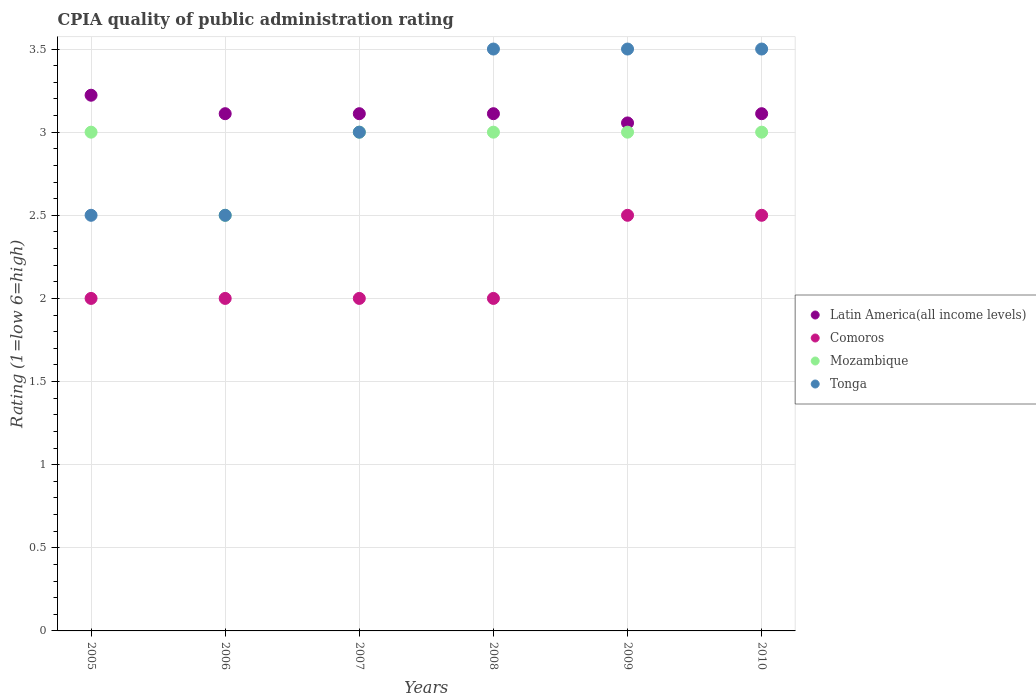How many different coloured dotlines are there?
Make the answer very short. 4. Is the number of dotlines equal to the number of legend labels?
Your answer should be very brief. Yes. What is the average CPIA rating in Comoros per year?
Give a very brief answer. 2.17. In the year 2007, what is the difference between the CPIA rating in Comoros and CPIA rating in Latin America(all income levels)?
Give a very brief answer. -1.11. Is the difference between the CPIA rating in Comoros in 2006 and 2008 greater than the difference between the CPIA rating in Latin America(all income levels) in 2006 and 2008?
Your answer should be very brief. No. What is the difference between the highest and the second highest CPIA rating in Latin America(all income levels)?
Provide a succinct answer. 0.11. What is the difference between the highest and the lowest CPIA rating in Mozambique?
Your answer should be very brief. 0.5. Is the sum of the CPIA rating in Latin America(all income levels) in 2005 and 2009 greater than the maximum CPIA rating in Comoros across all years?
Make the answer very short. Yes. Is it the case that in every year, the sum of the CPIA rating in Mozambique and CPIA rating in Comoros  is greater than the sum of CPIA rating in Latin America(all income levels) and CPIA rating in Tonga?
Offer a terse response. No. Is it the case that in every year, the sum of the CPIA rating in Tonga and CPIA rating in Latin America(all income levels)  is greater than the CPIA rating in Comoros?
Offer a terse response. Yes. Is the CPIA rating in Latin America(all income levels) strictly less than the CPIA rating in Comoros over the years?
Offer a terse response. No. How many dotlines are there?
Your answer should be very brief. 4. How many years are there in the graph?
Offer a very short reply. 6. What is the difference between two consecutive major ticks on the Y-axis?
Your answer should be very brief. 0.5. Does the graph contain any zero values?
Ensure brevity in your answer.  No. How many legend labels are there?
Your response must be concise. 4. What is the title of the graph?
Offer a very short reply. CPIA quality of public administration rating. What is the label or title of the Y-axis?
Your response must be concise. Rating (1=low 6=high). What is the Rating (1=low 6=high) of Latin America(all income levels) in 2005?
Your answer should be very brief. 3.22. What is the Rating (1=low 6=high) of Latin America(all income levels) in 2006?
Make the answer very short. 3.11. What is the Rating (1=low 6=high) of Comoros in 2006?
Ensure brevity in your answer.  2. What is the Rating (1=low 6=high) in Mozambique in 2006?
Offer a very short reply. 2.5. What is the Rating (1=low 6=high) of Latin America(all income levels) in 2007?
Ensure brevity in your answer.  3.11. What is the Rating (1=low 6=high) in Mozambique in 2007?
Your answer should be very brief. 3. What is the Rating (1=low 6=high) of Tonga in 2007?
Provide a succinct answer. 3. What is the Rating (1=low 6=high) in Latin America(all income levels) in 2008?
Make the answer very short. 3.11. What is the Rating (1=low 6=high) in Mozambique in 2008?
Provide a succinct answer. 3. What is the Rating (1=low 6=high) in Tonga in 2008?
Your response must be concise. 3.5. What is the Rating (1=low 6=high) of Latin America(all income levels) in 2009?
Keep it short and to the point. 3.06. What is the Rating (1=low 6=high) of Comoros in 2009?
Your response must be concise. 2.5. What is the Rating (1=low 6=high) in Mozambique in 2009?
Give a very brief answer. 3. What is the Rating (1=low 6=high) in Tonga in 2009?
Offer a very short reply. 3.5. What is the Rating (1=low 6=high) of Latin America(all income levels) in 2010?
Give a very brief answer. 3.11. What is the Rating (1=low 6=high) in Comoros in 2010?
Provide a short and direct response. 2.5. Across all years, what is the maximum Rating (1=low 6=high) in Latin America(all income levels)?
Give a very brief answer. 3.22. Across all years, what is the minimum Rating (1=low 6=high) of Latin America(all income levels)?
Give a very brief answer. 3.06. What is the total Rating (1=low 6=high) in Latin America(all income levels) in the graph?
Provide a succinct answer. 18.72. What is the total Rating (1=low 6=high) in Comoros in the graph?
Provide a succinct answer. 13. What is the total Rating (1=low 6=high) of Mozambique in the graph?
Provide a succinct answer. 17.5. What is the difference between the Rating (1=low 6=high) in Latin America(all income levels) in 2005 and that in 2006?
Your answer should be compact. 0.11. What is the difference between the Rating (1=low 6=high) in Mozambique in 2005 and that in 2006?
Ensure brevity in your answer.  0.5. What is the difference between the Rating (1=low 6=high) of Tonga in 2005 and that in 2006?
Provide a short and direct response. 0. What is the difference between the Rating (1=low 6=high) in Comoros in 2005 and that in 2007?
Your answer should be very brief. 0. What is the difference between the Rating (1=low 6=high) in Comoros in 2005 and that in 2008?
Provide a short and direct response. 0. What is the difference between the Rating (1=low 6=high) in Mozambique in 2005 and that in 2008?
Your response must be concise. 0. What is the difference between the Rating (1=low 6=high) in Tonga in 2005 and that in 2008?
Keep it short and to the point. -1. What is the difference between the Rating (1=low 6=high) of Latin America(all income levels) in 2005 and that in 2009?
Your answer should be compact. 0.17. What is the difference between the Rating (1=low 6=high) of Comoros in 2005 and that in 2009?
Offer a terse response. -0.5. What is the difference between the Rating (1=low 6=high) of Comoros in 2005 and that in 2010?
Make the answer very short. -0.5. What is the difference between the Rating (1=low 6=high) in Latin America(all income levels) in 2006 and that in 2007?
Keep it short and to the point. 0. What is the difference between the Rating (1=low 6=high) in Comoros in 2006 and that in 2007?
Provide a succinct answer. 0. What is the difference between the Rating (1=low 6=high) of Tonga in 2006 and that in 2007?
Offer a very short reply. -0.5. What is the difference between the Rating (1=low 6=high) of Comoros in 2006 and that in 2008?
Provide a short and direct response. 0. What is the difference between the Rating (1=low 6=high) in Mozambique in 2006 and that in 2008?
Your response must be concise. -0.5. What is the difference between the Rating (1=low 6=high) of Latin America(all income levels) in 2006 and that in 2009?
Give a very brief answer. 0.06. What is the difference between the Rating (1=low 6=high) of Mozambique in 2006 and that in 2009?
Offer a very short reply. -0.5. What is the difference between the Rating (1=low 6=high) in Comoros in 2007 and that in 2008?
Provide a succinct answer. 0. What is the difference between the Rating (1=low 6=high) in Tonga in 2007 and that in 2008?
Your answer should be compact. -0.5. What is the difference between the Rating (1=low 6=high) of Latin America(all income levels) in 2007 and that in 2009?
Offer a very short reply. 0.06. What is the difference between the Rating (1=low 6=high) of Comoros in 2007 and that in 2010?
Ensure brevity in your answer.  -0.5. What is the difference between the Rating (1=low 6=high) of Tonga in 2007 and that in 2010?
Your response must be concise. -0.5. What is the difference between the Rating (1=low 6=high) in Latin America(all income levels) in 2008 and that in 2009?
Give a very brief answer. 0.06. What is the difference between the Rating (1=low 6=high) in Comoros in 2008 and that in 2009?
Offer a very short reply. -0.5. What is the difference between the Rating (1=low 6=high) in Mozambique in 2008 and that in 2009?
Your response must be concise. 0. What is the difference between the Rating (1=low 6=high) in Tonga in 2008 and that in 2009?
Provide a short and direct response. 0. What is the difference between the Rating (1=low 6=high) in Latin America(all income levels) in 2008 and that in 2010?
Your answer should be compact. 0. What is the difference between the Rating (1=low 6=high) in Comoros in 2008 and that in 2010?
Your response must be concise. -0.5. What is the difference between the Rating (1=low 6=high) in Mozambique in 2008 and that in 2010?
Ensure brevity in your answer.  0. What is the difference between the Rating (1=low 6=high) in Latin America(all income levels) in 2009 and that in 2010?
Your answer should be compact. -0.06. What is the difference between the Rating (1=low 6=high) in Comoros in 2009 and that in 2010?
Keep it short and to the point. 0. What is the difference between the Rating (1=low 6=high) in Latin America(all income levels) in 2005 and the Rating (1=low 6=high) in Comoros in 2006?
Make the answer very short. 1.22. What is the difference between the Rating (1=low 6=high) in Latin America(all income levels) in 2005 and the Rating (1=low 6=high) in Mozambique in 2006?
Your response must be concise. 0.72. What is the difference between the Rating (1=low 6=high) of Latin America(all income levels) in 2005 and the Rating (1=low 6=high) of Tonga in 2006?
Ensure brevity in your answer.  0.72. What is the difference between the Rating (1=low 6=high) in Latin America(all income levels) in 2005 and the Rating (1=low 6=high) in Comoros in 2007?
Your answer should be very brief. 1.22. What is the difference between the Rating (1=low 6=high) of Latin America(all income levels) in 2005 and the Rating (1=low 6=high) of Mozambique in 2007?
Your response must be concise. 0.22. What is the difference between the Rating (1=low 6=high) in Latin America(all income levels) in 2005 and the Rating (1=low 6=high) in Tonga in 2007?
Provide a short and direct response. 0.22. What is the difference between the Rating (1=low 6=high) of Comoros in 2005 and the Rating (1=low 6=high) of Mozambique in 2007?
Offer a terse response. -1. What is the difference between the Rating (1=low 6=high) of Comoros in 2005 and the Rating (1=low 6=high) of Tonga in 2007?
Make the answer very short. -1. What is the difference between the Rating (1=low 6=high) of Mozambique in 2005 and the Rating (1=low 6=high) of Tonga in 2007?
Provide a short and direct response. 0. What is the difference between the Rating (1=low 6=high) in Latin America(all income levels) in 2005 and the Rating (1=low 6=high) in Comoros in 2008?
Keep it short and to the point. 1.22. What is the difference between the Rating (1=low 6=high) of Latin America(all income levels) in 2005 and the Rating (1=low 6=high) of Mozambique in 2008?
Make the answer very short. 0.22. What is the difference between the Rating (1=low 6=high) of Latin America(all income levels) in 2005 and the Rating (1=low 6=high) of Tonga in 2008?
Make the answer very short. -0.28. What is the difference between the Rating (1=low 6=high) in Comoros in 2005 and the Rating (1=low 6=high) in Mozambique in 2008?
Offer a very short reply. -1. What is the difference between the Rating (1=low 6=high) in Latin America(all income levels) in 2005 and the Rating (1=low 6=high) in Comoros in 2009?
Give a very brief answer. 0.72. What is the difference between the Rating (1=low 6=high) in Latin America(all income levels) in 2005 and the Rating (1=low 6=high) in Mozambique in 2009?
Offer a terse response. 0.22. What is the difference between the Rating (1=low 6=high) in Latin America(all income levels) in 2005 and the Rating (1=low 6=high) in Tonga in 2009?
Make the answer very short. -0.28. What is the difference between the Rating (1=low 6=high) in Comoros in 2005 and the Rating (1=low 6=high) in Tonga in 2009?
Provide a succinct answer. -1.5. What is the difference between the Rating (1=low 6=high) of Latin America(all income levels) in 2005 and the Rating (1=low 6=high) of Comoros in 2010?
Your response must be concise. 0.72. What is the difference between the Rating (1=low 6=high) in Latin America(all income levels) in 2005 and the Rating (1=low 6=high) in Mozambique in 2010?
Your answer should be compact. 0.22. What is the difference between the Rating (1=low 6=high) of Latin America(all income levels) in 2005 and the Rating (1=low 6=high) of Tonga in 2010?
Provide a short and direct response. -0.28. What is the difference between the Rating (1=low 6=high) in Comoros in 2005 and the Rating (1=low 6=high) in Tonga in 2010?
Give a very brief answer. -1.5. What is the difference between the Rating (1=low 6=high) of Latin America(all income levels) in 2006 and the Rating (1=low 6=high) of Mozambique in 2007?
Keep it short and to the point. 0.11. What is the difference between the Rating (1=low 6=high) in Latin America(all income levels) in 2006 and the Rating (1=low 6=high) in Tonga in 2007?
Provide a short and direct response. 0.11. What is the difference between the Rating (1=low 6=high) of Comoros in 2006 and the Rating (1=low 6=high) of Mozambique in 2007?
Offer a very short reply. -1. What is the difference between the Rating (1=low 6=high) in Mozambique in 2006 and the Rating (1=low 6=high) in Tonga in 2007?
Your answer should be very brief. -0.5. What is the difference between the Rating (1=low 6=high) in Latin America(all income levels) in 2006 and the Rating (1=low 6=high) in Comoros in 2008?
Your answer should be compact. 1.11. What is the difference between the Rating (1=low 6=high) of Latin America(all income levels) in 2006 and the Rating (1=low 6=high) of Mozambique in 2008?
Offer a very short reply. 0.11. What is the difference between the Rating (1=low 6=high) of Latin America(all income levels) in 2006 and the Rating (1=low 6=high) of Tonga in 2008?
Give a very brief answer. -0.39. What is the difference between the Rating (1=low 6=high) of Latin America(all income levels) in 2006 and the Rating (1=low 6=high) of Comoros in 2009?
Offer a terse response. 0.61. What is the difference between the Rating (1=low 6=high) of Latin America(all income levels) in 2006 and the Rating (1=low 6=high) of Mozambique in 2009?
Offer a terse response. 0.11. What is the difference between the Rating (1=low 6=high) in Latin America(all income levels) in 2006 and the Rating (1=low 6=high) in Tonga in 2009?
Offer a very short reply. -0.39. What is the difference between the Rating (1=low 6=high) in Comoros in 2006 and the Rating (1=low 6=high) in Tonga in 2009?
Offer a terse response. -1.5. What is the difference between the Rating (1=low 6=high) in Latin America(all income levels) in 2006 and the Rating (1=low 6=high) in Comoros in 2010?
Provide a short and direct response. 0.61. What is the difference between the Rating (1=low 6=high) in Latin America(all income levels) in 2006 and the Rating (1=low 6=high) in Mozambique in 2010?
Offer a very short reply. 0.11. What is the difference between the Rating (1=low 6=high) of Latin America(all income levels) in 2006 and the Rating (1=low 6=high) of Tonga in 2010?
Your response must be concise. -0.39. What is the difference between the Rating (1=low 6=high) in Comoros in 2006 and the Rating (1=low 6=high) in Mozambique in 2010?
Offer a very short reply. -1. What is the difference between the Rating (1=low 6=high) of Mozambique in 2006 and the Rating (1=low 6=high) of Tonga in 2010?
Provide a succinct answer. -1. What is the difference between the Rating (1=low 6=high) of Latin America(all income levels) in 2007 and the Rating (1=low 6=high) of Tonga in 2008?
Ensure brevity in your answer.  -0.39. What is the difference between the Rating (1=low 6=high) in Comoros in 2007 and the Rating (1=low 6=high) in Tonga in 2008?
Offer a very short reply. -1.5. What is the difference between the Rating (1=low 6=high) of Latin America(all income levels) in 2007 and the Rating (1=low 6=high) of Comoros in 2009?
Offer a terse response. 0.61. What is the difference between the Rating (1=low 6=high) of Latin America(all income levels) in 2007 and the Rating (1=low 6=high) of Mozambique in 2009?
Provide a succinct answer. 0.11. What is the difference between the Rating (1=low 6=high) of Latin America(all income levels) in 2007 and the Rating (1=low 6=high) of Tonga in 2009?
Make the answer very short. -0.39. What is the difference between the Rating (1=low 6=high) of Latin America(all income levels) in 2007 and the Rating (1=low 6=high) of Comoros in 2010?
Provide a short and direct response. 0.61. What is the difference between the Rating (1=low 6=high) of Latin America(all income levels) in 2007 and the Rating (1=low 6=high) of Mozambique in 2010?
Your answer should be very brief. 0.11. What is the difference between the Rating (1=low 6=high) in Latin America(all income levels) in 2007 and the Rating (1=low 6=high) in Tonga in 2010?
Your answer should be very brief. -0.39. What is the difference between the Rating (1=low 6=high) in Mozambique in 2007 and the Rating (1=low 6=high) in Tonga in 2010?
Offer a very short reply. -0.5. What is the difference between the Rating (1=low 6=high) in Latin America(all income levels) in 2008 and the Rating (1=low 6=high) in Comoros in 2009?
Provide a succinct answer. 0.61. What is the difference between the Rating (1=low 6=high) of Latin America(all income levels) in 2008 and the Rating (1=low 6=high) of Tonga in 2009?
Offer a terse response. -0.39. What is the difference between the Rating (1=low 6=high) in Comoros in 2008 and the Rating (1=low 6=high) in Mozambique in 2009?
Offer a terse response. -1. What is the difference between the Rating (1=low 6=high) in Latin America(all income levels) in 2008 and the Rating (1=low 6=high) in Comoros in 2010?
Your response must be concise. 0.61. What is the difference between the Rating (1=low 6=high) in Latin America(all income levels) in 2008 and the Rating (1=low 6=high) in Tonga in 2010?
Keep it short and to the point. -0.39. What is the difference between the Rating (1=low 6=high) in Comoros in 2008 and the Rating (1=low 6=high) in Mozambique in 2010?
Your answer should be very brief. -1. What is the difference between the Rating (1=low 6=high) in Comoros in 2008 and the Rating (1=low 6=high) in Tonga in 2010?
Ensure brevity in your answer.  -1.5. What is the difference between the Rating (1=low 6=high) in Mozambique in 2008 and the Rating (1=low 6=high) in Tonga in 2010?
Make the answer very short. -0.5. What is the difference between the Rating (1=low 6=high) in Latin America(all income levels) in 2009 and the Rating (1=low 6=high) in Comoros in 2010?
Offer a terse response. 0.56. What is the difference between the Rating (1=low 6=high) of Latin America(all income levels) in 2009 and the Rating (1=low 6=high) of Mozambique in 2010?
Provide a succinct answer. 0.06. What is the difference between the Rating (1=low 6=high) of Latin America(all income levels) in 2009 and the Rating (1=low 6=high) of Tonga in 2010?
Your answer should be compact. -0.44. What is the difference between the Rating (1=low 6=high) of Comoros in 2009 and the Rating (1=low 6=high) of Mozambique in 2010?
Make the answer very short. -0.5. What is the difference between the Rating (1=low 6=high) of Comoros in 2009 and the Rating (1=low 6=high) of Tonga in 2010?
Offer a terse response. -1. What is the average Rating (1=low 6=high) of Latin America(all income levels) per year?
Your answer should be very brief. 3.12. What is the average Rating (1=low 6=high) in Comoros per year?
Offer a very short reply. 2.17. What is the average Rating (1=low 6=high) of Mozambique per year?
Your answer should be compact. 2.92. What is the average Rating (1=low 6=high) in Tonga per year?
Ensure brevity in your answer.  3.08. In the year 2005, what is the difference between the Rating (1=low 6=high) in Latin America(all income levels) and Rating (1=low 6=high) in Comoros?
Provide a succinct answer. 1.22. In the year 2005, what is the difference between the Rating (1=low 6=high) of Latin America(all income levels) and Rating (1=low 6=high) of Mozambique?
Offer a very short reply. 0.22. In the year 2005, what is the difference between the Rating (1=low 6=high) in Latin America(all income levels) and Rating (1=low 6=high) in Tonga?
Offer a terse response. 0.72. In the year 2005, what is the difference between the Rating (1=low 6=high) of Comoros and Rating (1=low 6=high) of Tonga?
Your response must be concise. -0.5. In the year 2005, what is the difference between the Rating (1=low 6=high) in Mozambique and Rating (1=low 6=high) in Tonga?
Offer a very short reply. 0.5. In the year 2006, what is the difference between the Rating (1=low 6=high) of Latin America(all income levels) and Rating (1=low 6=high) of Comoros?
Provide a short and direct response. 1.11. In the year 2006, what is the difference between the Rating (1=low 6=high) in Latin America(all income levels) and Rating (1=low 6=high) in Mozambique?
Keep it short and to the point. 0.61. In the year 2006, what is the difference between the Rating (1=low 6=high) of Latin America(all income levels) and Rating (1=low 6=high) of Tonga?
Keep it short and to the point. 0.61. In the year 2006, what is the difference between the Rating (1=low 6=high) of Comoros and Rating (1=low 6=high) of Mozambique?
Offer a very short reply. -0.5. In the year 2006, what is the difference between the Rating (1=low 6=high) in Comoros and Rating (1=low 6=high) in Tonga?
Offer a very short reply. -0.5. In the year 2006, what is the difference between the Rating (1=low 6=high) of Mozambique and Rating (1=low 6=high) of Tonga?
Provide a succinct answer. 0. In the year 2007, what is the difference between the Rating (1=low 6=high) in Latin America(all income levels) and Rating (1=low 6=high) in Mozambique?
Your answer should be very brief. 0.11. In the year 2007, what is the difference between the Rating (1=low 6=high) of Latin America(all income levels) and Rating (1=low 6=high) of Tonga?
Keep it short and to the point. 0.11. In the year 2007, what is the difference between the Rating (1=low 6=high) in Comoros and Rating (1=low 6=high) in Mozambique?
Your response must be concise. -1. In the year 2008, what is the difference between the Rating (1=low 6=high) in Latin America(all income levels) and Rating (1=low 6=high) in Mozambique?
Your response must be concise. 0.11. In the year 2008, what is the difference between the Rating (1=low 6=high) of Latin America(all income levels) and Rating (1=low 6=high) of Tonga?
Your answer should be compact. -0.39. In the year 2008, what is the difference between the Rating (1=low 6=high) in Comoros and Rating (1=low 6=high) in Mozambique?
Provide a succinct answer. -1. In the year 2008, what is the difference between the Rating (1=low 6=high) in Mozambique and Rating (1=low 6=high) in Tonga?
Give a very brief answer. -0.5. In the year 2009, what is the difference between the Rating (1=low 6=high) of Latin America(all income levels) and Rating (1=low 6=high) of Comoros?
Make the answer very short. 0.56. In the year 2009, what is the difference between the Rating (1=low 6=high) of Latin America(all income levels) and Rating (1=low 6=high) of Mozambique?
Offer a terse response. 0.06. In the year 2009, what is the difference between the Rating (1=low 6=high) in Latin America(all income levels) and Rating (1=low 6=high) in Tonga?
Your answer should be compact. -0.44. In the year 2010, what is the difference between the Rating (1=low 6=high) in Latin America(all income levels) and Rating (1=low 6=high) in Comoros?
Give a very brief answer. 0.61. In the year 2010, what is the difference between the Rating (1=low 6=high) of Latin America(all income levels) and Rating (1=low 6=high) of Tonga?
Make the answer very short. -0.39. In the year 2010, what is the difference between the Rating (1=low 6=high) of Comoros and Rating (1=low 6=high) of Tonga?
Offer a very short reply. -1. In the year 2010, what is the difference between the Rating (1=low 6=high) in Mozambique and Rating (1=low 6=high) in Tonga?
Provide a short and direct response. -0.5. What is the ratio of the Rating (1=low 6=high) in Latin America(all income levels) in 2005 to that in 2006?
Your answer should be very brief. 1.04. What is the ratio of the Rating (1=low 6=high) in Tonga in 2005 to that in 2006?
Give a very brief answer. 1. What is the ratio of the Rating (1=low 6=high) in Latin America(all income levels) in 2005 to that in 2007?
Provide a short and direct response. 1.04. What is the ratio of the Rating (1=low 6=high) in Mozambique in 2005 to that in 2007?
Your response must be concise. 1. What is the ratio of the Rating (1=low 6=high) of Latin America(all income levels) in 2005 to that in 2008?
Ensure brevity in your answer.  1.04. What is the ratio of the Rating (1=low 6=high) of Comoros in 2005 to that in 2008?
Give a very brief answer. 1. What is the ratio of the Rating (1=low 6=high) of Mozambique in 2005 to that in 2008?
Offer a very short reply. 1. What is the ratio of the Rating (1=low 6=high) of Tonga in 2005 to that in 2008?
Provide a short and direct response. 0.71. What is the ratio of the Rating (1=low 6=high) of Latin America(all income levels) in 2005 to that in 2009?
Your response must be concise. 1.05. What is the ratio of the Rating (1=low 6=high) of Comoros in 2005 to that in 2009?
Provide a short and direct response. 0.8. What is the ratio of the Rating (1=low 6=high) in Tonga in 2005 to that in 2009?
Keep it short and to the point. 0.71. What is the ratio of the Rating (1=low 6=high) in Latin America(all income levels) in 2005 to that in 2010?
Keep it short and to the point. 1.04. What is the ratio of the Rating (1=low 6=high) in Comoros in 2005 to that in 2010?
Give a very brief answer. 0.8. What is the ratio of the Rating (1=low 6=high) of Tonga in 2005 to that in 2010?
Provide a short and direct response. 0.71. What is the ratio of the Rating (1=low 6=high) in Latin America(all income levels) in 2006 to that in 2007?
Keep it short and to the point. 1. What is the ratio of the Rating (1=low 6=high) in Comoros in 2006 to that in 2007?
Keep it short and to the point. 1. What is the ratio of the Rating (1=low 6=high) of Tonga in 2006 to that in 2007?
Give a very brief answer. 0.83. What is the ratio of the Rating (1=low 6=high) in Latin America(all income levels) in 2006 to that in 2008?
Your answer should be compact. 1. What is the ratio of the Rating (1=low 6=high) of Mozambique in 2006 to that in 2008?
Provide a short and direct response. 0.83. What is the ratio of the Rating (1=low 6=high) of Tonga in 2006 to that in 2008?
Your answer should be compact. 0.71. What is the ratio of the Rating (1=low 6=high) in Latin America(all income levels) in 2006 to that in 2009?
Your answer should be compact. 1.02. What is the ratio of the Rating (1=low 6=high) of Comoros in 2006 to that in 2009?
Provide a succinct answer. 0.8. What is the ratio of the Rating (1=low 6=high) of Tonga in 2006 to that in 2009?
Provide a succinct answer. 0.71. What is the ratio of the Rating (1=low 6=high) of Latin America(all income levels) in 2006 to that in 2010?
Offer a terse response. 1. What is the ratio of the Rating (1=low 6=high) of Mozambique in 2007 to that in 2008?
Offer a terse response. 1. What is the ratio of the Rating (1=low 6=high) of Tonga in 2007 to that in 2008?
Offer a very short reply. 0.86. What is the ratio of the Rating (1=low 6=high) of Latin America(all income levels) in 2007 to that in 2009?
Keep it short and to the point. 1.02. What is the ratio of the Rating (1=low 6=high) in Tonga in 2007 to that in 2009?
Your answer should be very brief. 0.86. What is the ratio of the Rating (1=low 6=high) of Mozambique in 2007 to that in 2010?
Offer a terse response. 1. What is the ratio of the Rating (1=low 6=high) in Latin America(all income levels) in 2008 to that in 2009?
Offer a very short reply. 1.02. What is the ratio of the Rating (1=low 6=high) in Comoros in 2008 to that in 2009?
Provide a short and direct response. 0.8. What is the ratio of the Rating (1=low 6=high) in Mozambique in 2008 to that in 2009?
Offer a terse response. 1. What is the ratio of the Rating (1=low 6=high) in Latin America(all income levels) in 2008 to that in 2010?
Ensure brevity in your answer.  1. What is the ratio of the Rating (1=low 6=high) of Tonga in 2008 to that in 2010?
Give a very brief answer. 1. What is the ratio of the Rating (1=low 6=high) of Latin America(all income levels) in 2009 to that in 2010?
Provide a short and direct response. 0.98. What is the ratio of the Rating (1=low 6=high) in Comoros in 2009 to that in 2010?
Your response must be concise. 1. What is the ratio of the Rating (1=low 6=high) in Mozambique in 2009 to that in 2010?
Provide a succinct answer. 1. What is the difference between the highest and the second highest Rating (1=low 6=high) of Latin America(all income levels)?
Your answer should be compact. 0.11. What is the difference between the highest and the lowest Rating (1=low 6=high) of Latin America(all income levels)?
Provide a short and direct response. 0.17. What is the difference between the highest and the lowest Rating (1=low 6=high) of Comoros?
Give a very brief answer. 0.5. What is the difference between the highest and the lowest Rating (1=low 6=high) in Tonga?
Provide a succinct answer. 1. 